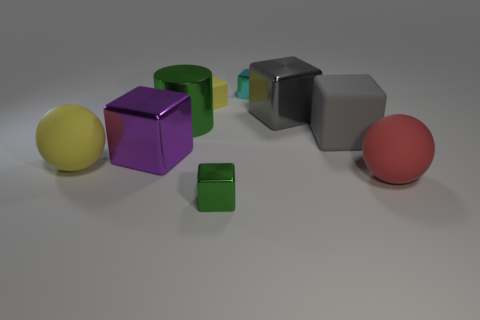What shape is the matte object that is on the right side of the tiny rubber thing and to the left of the red rubber sphere? The matte object situated to the right of the tiny green cube and to the left of the red rubber sphere is also a cube, featuring a grey color with a non-reflective surface. 